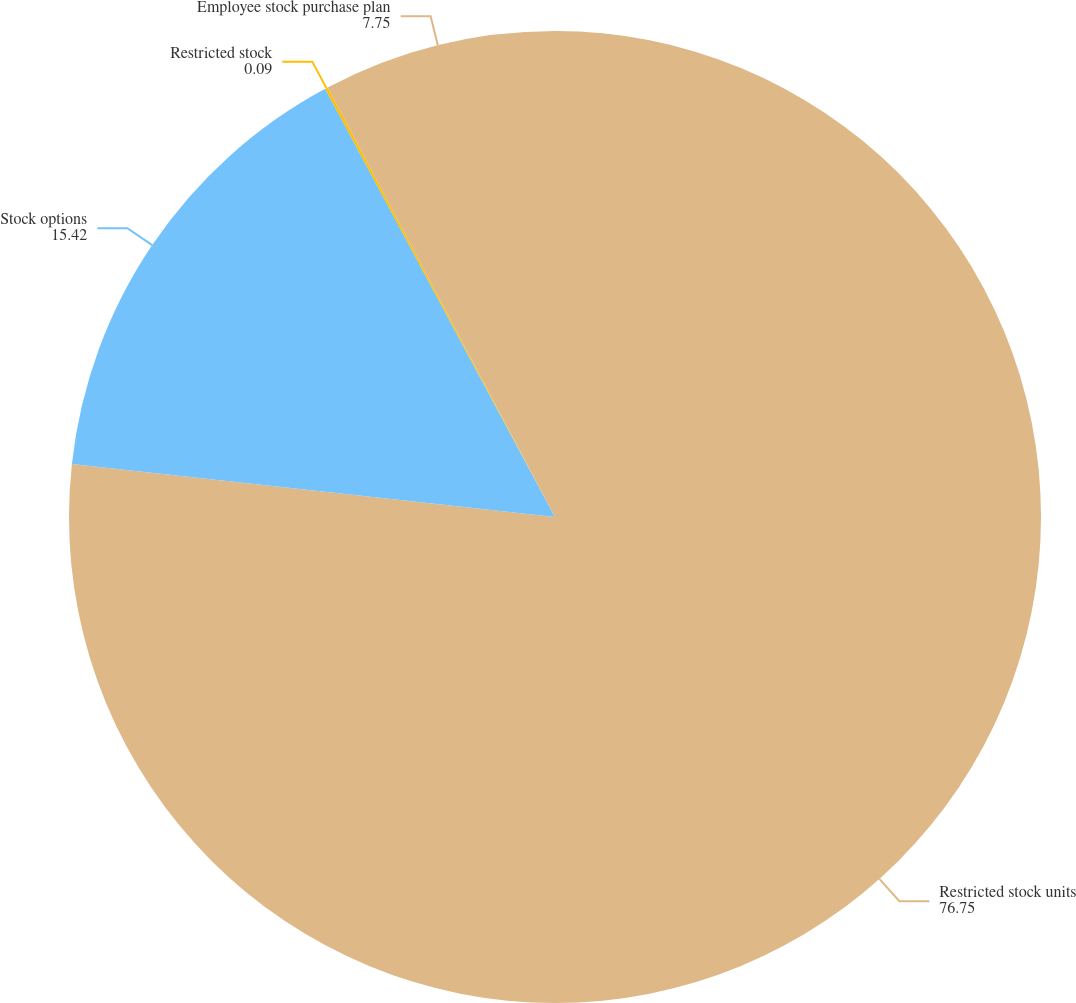<chart> <loc_0><loc_0><loc_500><loc_500><pie_chart><fcel>Restricted stock units<fcel>Stock options<fcel>Restricted stock<fcel>Employee stock purchase plan<nl><fcel>76.75%<fcel>15.42%<fcel>0.09%<fcel>7.75%<nl></chart> 